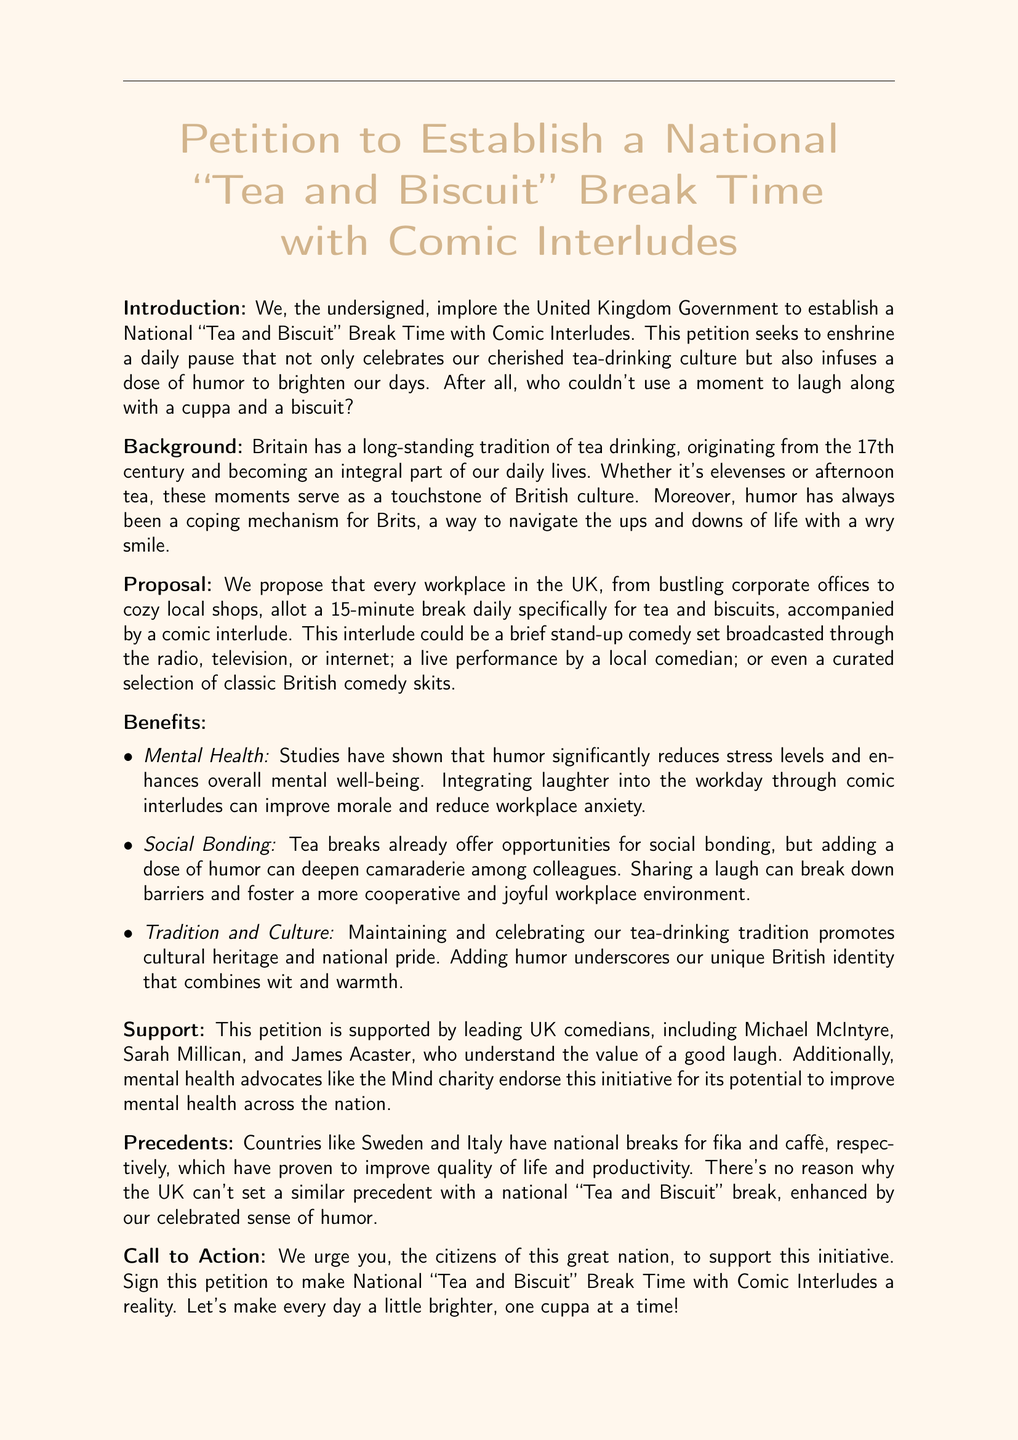What is the title of the petition? The title of the petition is found at the top of the document indicating its purpose, which is to establish a National "Tea and Biscuit" Break Time with Comic Interludes.
Answer: Petition to Establish a National "Tea and Biscuit" Break Time with Comic Interludes Who supports the petition? The document lists leading UK comedians and mental health advocates who support the petition, highlighting their backing as significant.
Answer: Michael McIntyre, Sarah Millican, and James Acaster What is the proposed duration for the tea and biscuit break? The document specifies that the proposed duration for the tea and biscuit break is explicitly mentioned in the proposal section.
Answer: 15 minutes What is one proposed medium for the comic interlude? The proposal section specifies various mediums for the comic interlude, demonstrating creativity in how humor could be integrated into the break.
Answer: Radio What are the potential benefits of the tea break? The benefits section lists several advantages, emphasizing the positive impacts on mental health, social bonding, and tradition.
Answer: Mental Health Which countries are cited as precedents for national breaks? The document references countries that have established similar cultural practices that improve quality of life, reinforcing the argument for a national break.
Answer: Sweden and Italy What style of document is this? The structure and content indicate that this type of document is commonly used to solicit support for a cause or initiative from a community or government body.
Answer: Petition What does the petition aim to address? The introduction outlines the main objective of the petition, emphasizing a cultural aspect that is significant to the British people.
Answer: Tea-drinking culture 